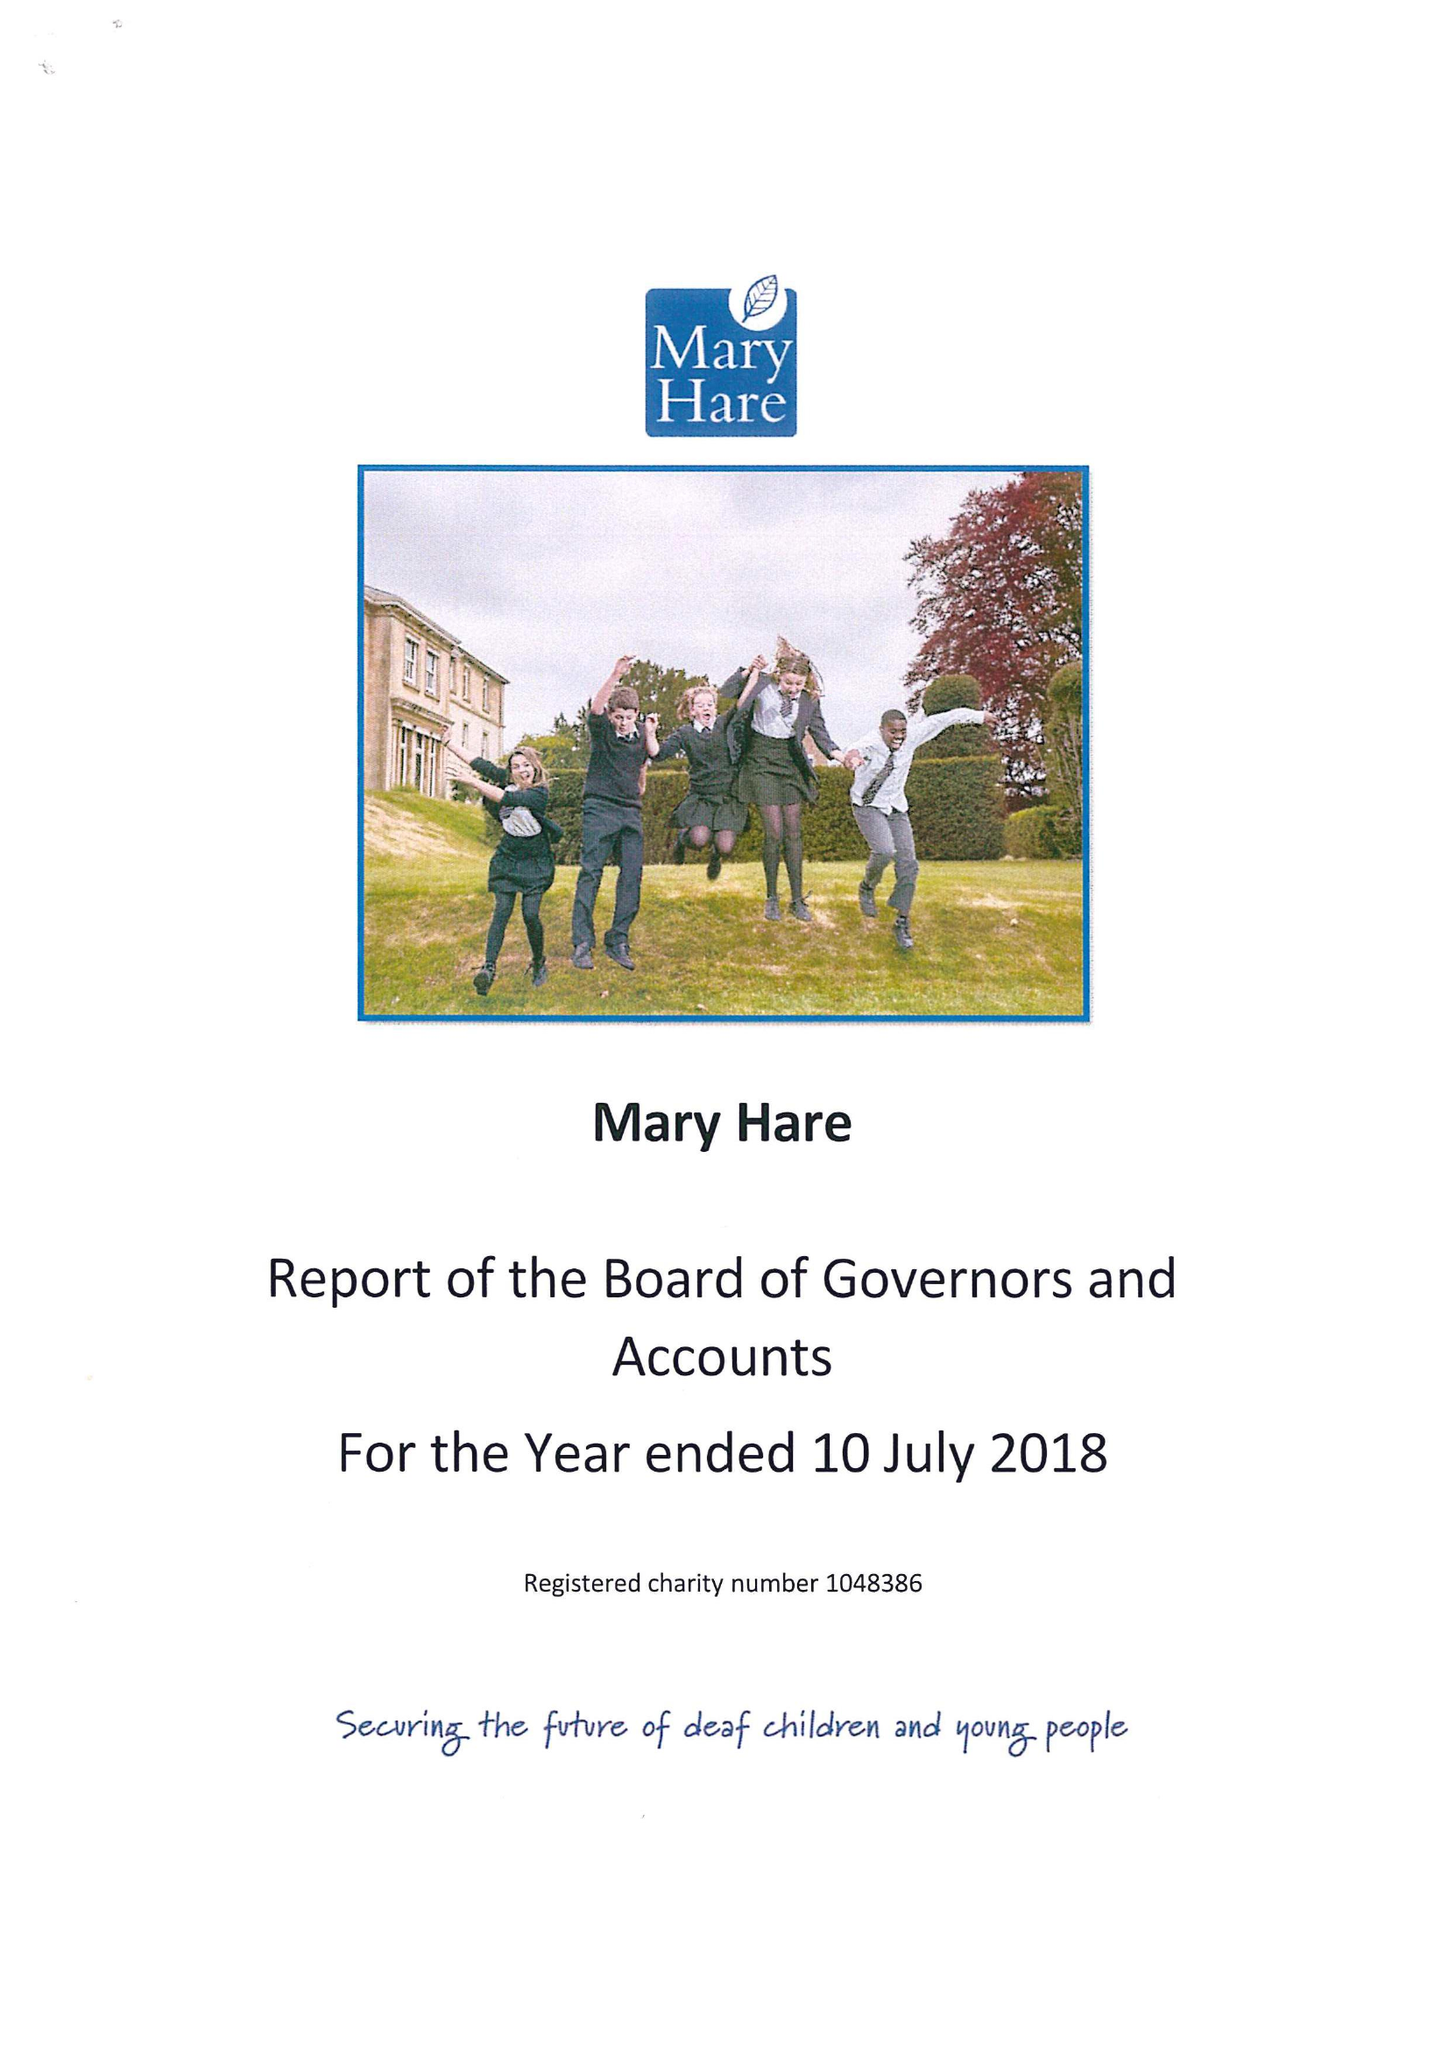What is the value for the address__postcode?
Answer the question using a single word or phrase. RG14 3BQ 